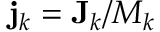Convert formula to latex. <formula><loc_0><loc_0><loc_500><loc_500>{ j } _ { k } = { J } _ { k } / M _ { k }</formula> 